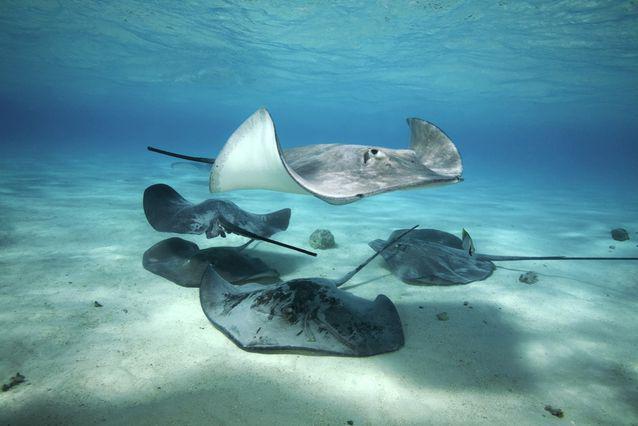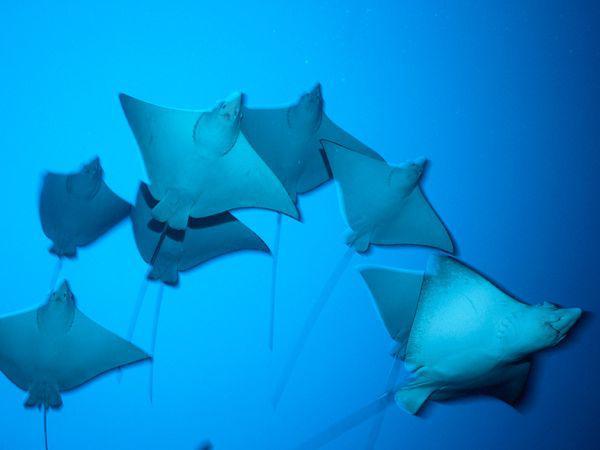The first image is the image on the left, the second image is the image on the right. For the images shown, is this caption "The left image contains no more than five sting rays." true? Answer yes or no. Yes. 